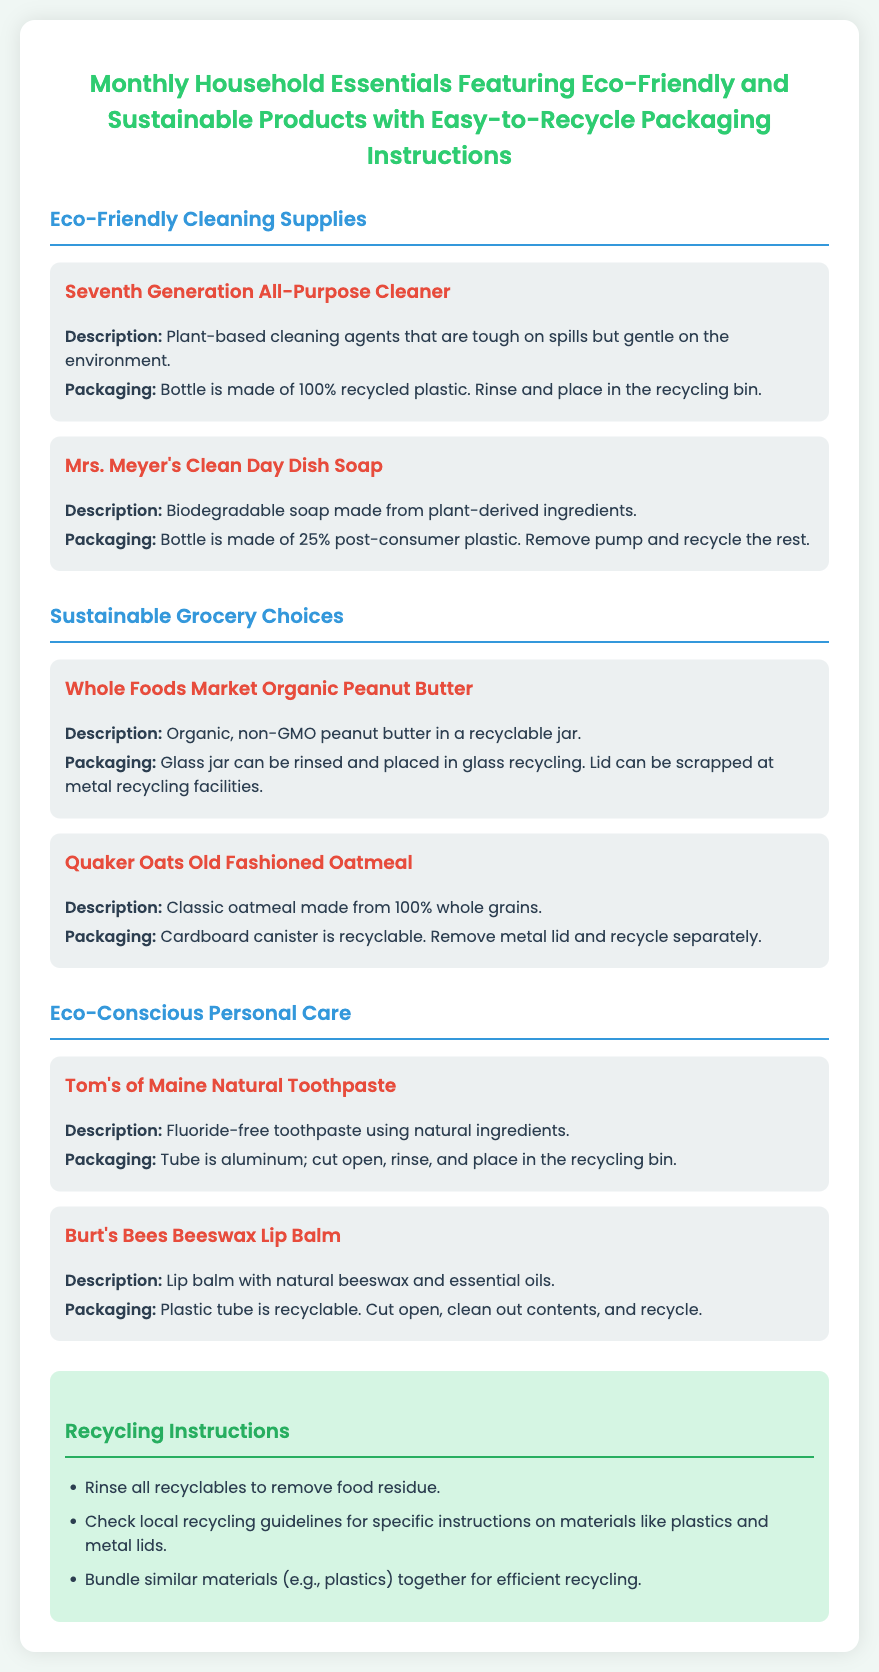what is the title of the document? The title of the document is prominently displayed at the top of the shipping label.
Answer: Monthly Household Essentials Featuring Eco-Friendly and Sustainable Products with Easy-to-Recycle Packaging Instructions how many eco-friendly cleaning supplies are listed? The document categorizes products, and I can count them under the Eco-Friendly Cleaning Supplies section.
Answer: 2 what packaging material is used for the Seventh Generation All-Purpose Cleaner? The packaging details for each product are mentioned in their respective sections.
Answer: 100% recycled plastic what type of product is Mrs. Meyer's Clean Day Dish Soap? Each product's description provides insight into its category.
Answer: Biodegradable soap how should the packaging of Tom's of Maine Natural Toothpaste be disposed of? The recycling instructions for each product clarify how to handle their packaging.
Answer: cut open, rinse, and place in the recycling bin what is required for recycling the lid of the Whole Foods Market Organic Peanut Butter? The packaging instructions include recycling details about different components.
Answer: scrapped at metal recycling facilities how many products are categorized under Sustainable Grocery Choices? The number of products in each category can be determined by counting them in the relevant section.
Answer: 2 what color is the background of the document? The overall appearance, including the background color, can be observed in the document's styling.
Answer: #f0f7f4 what should you do before placing recyclables in the bin? The recycling instructions specify a necessary step before recycling.
Answer: rinse all recyclables to remove food residue 